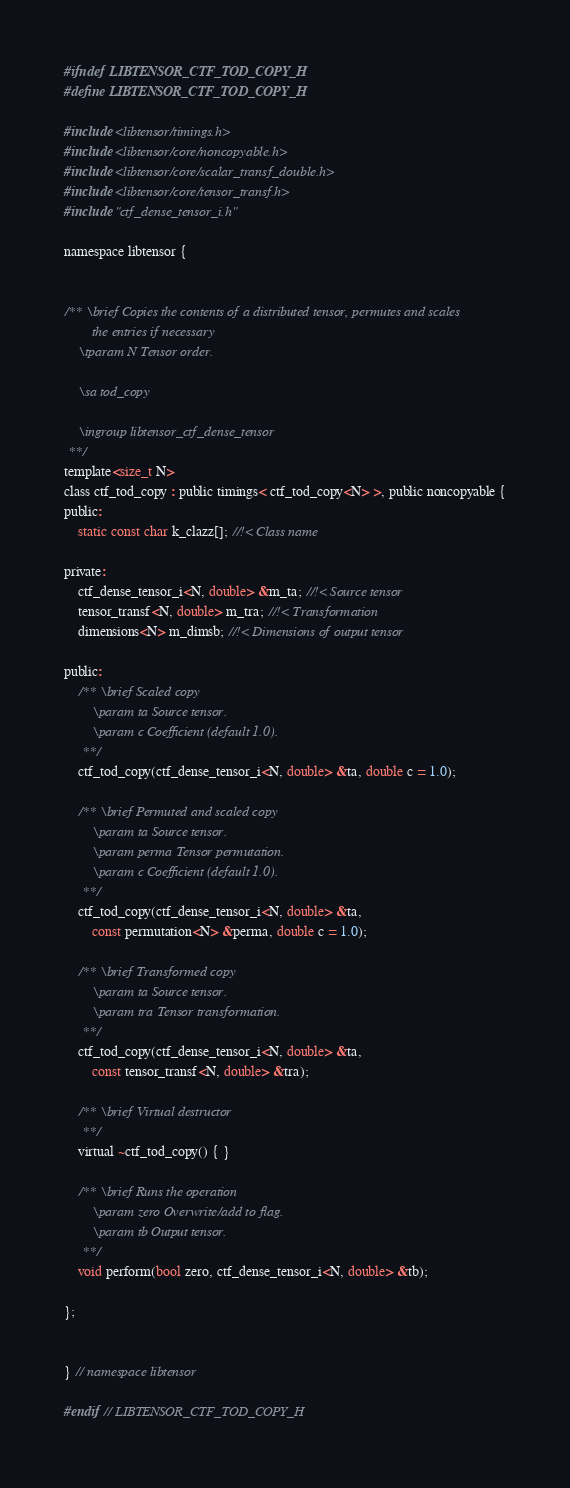Convert code to text. <code><loc_0><loc_0><loc_500><loc_500><_C_>#ifndef LIBTENSOR_CTF_TOD_COPY_H
#define LIBTENSOR_CTF_TOD_COPY_H

#include <libtensor/timings.h>
#include <libtensor/core/noncopyable.h>
#include <libtensor/core/scalar_transf_double.h>
#include <libtensor/core/tensor_transf.h>
#include "ctf_dense_tensor_i.h"

namespace libtensor {


/** \brief Copies the contents of a distributed tensor, permutes and scales
        the entries if necessary
    \tparam N Tensor order.

    \sa tod_copy

    \ingroup libtensor_ctf_dense_tensor
 **/
template<size_t N>
class ctf_tod_copy : public timings< ctf_tod_copy<N> >, public noncopyable {
public:
    static const char k_clazz[]; //!< Class name

private:
    ctf_dense_tensor_i<N, double> &m_ta; //!< Source tensor
    tensor_transf<N, double> m_tra; //!< Transformation
    dimensions<N> m_dimsb; //!< Dimensions of output tensor

public:
    /** \brief Scaled copy
        \param ta Source tensor.
        \param c Coefficient (default 1.0).
     **/
    ctf_tod_copy(ctf_dense_tensor_i<N, double> &ta, double c = 1.0);

    /** \brief Permuted and scaled copy
        \param ta Source tensor.
        \param perma Tensor permutation.
        \param c Coefficient (default 1.0).
     **/
    ctf_tod_copy(ctf_dense_tensor_i<N, double> &ta,
        const permutation<N> &perma, double c = 1.0);

    /** \brief Transformed copy
        \param ta Source tensor.
        \param tra Tensor transformation.
     **/
    ctf_tod_copy(ctf_dense_tensor_i<N, double> &ta,
        const tensor_transf<N, double> &tra);

    /** \brief Virtual destructor
     **/
    virtual ~ctf_tod_copy() { }

    /** \brief Runs the operation
        \param zero Overwrite/add to flag.
        \param tb Output tensor.
     **/
    void perform(bool zero, ctf_dense_tensor_i<N, double> &tb);

};


} // namespace libtensor

#endif // LIBTENSOR_CTF_TOD_COPY_H
</code> 